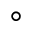Convert formula to latex. <formula><loc_0><loc_0><loc_500><loc_500>^ { \circ }</formula> 